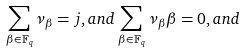Convert formula to latex. <formula><loc_0><loc_0><loc_500><loc_500>\sum _ { \beta \in \mathbb { F } _ { q } } { \nu _ { \beta } } = j , a n d \sum _ { \beta \in \mathbb { F } _ { q } } { \nu _ { \beta } } { \beta } = 0 , a n d \\</formula> 